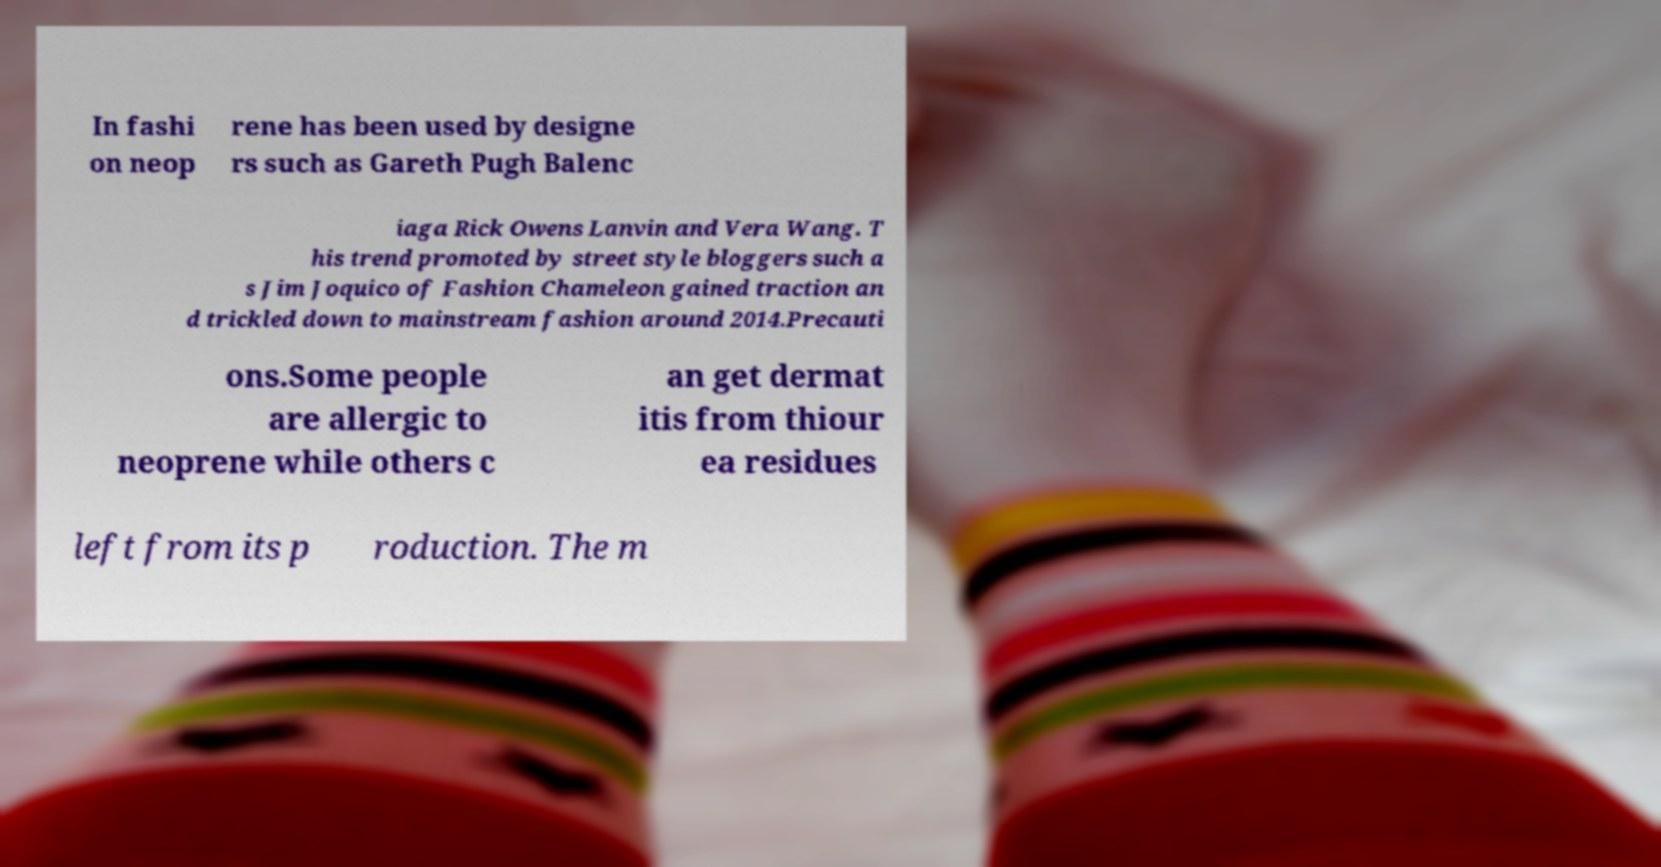What messages or text are displayed in this image? I need them in a readable, typed format. In fashi on neop rene has been used by designe rs such as Gareth Pugh Balenc iaga Rick Owens Lanvin and Vera Wang. T his trend promoted by street style bloggers such a s Jim Joquico of Fashion Chameleon gained traction an d trickled down to mainstream fashion around 2014.Precauti ons.Some people are allergic to neoprene while others c an get dermat itis from thiour ea residues left from its p roduction. The m 